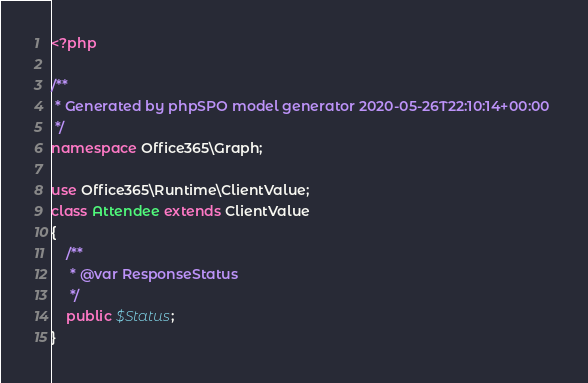<code> <loc_0><loc_0><loc_500><loc_500><_PHP_><?php

/**
 * Generated by phpSPO model generator 2020-05-26T22:10:14+00:00 
 */
namespace Office365\Graph;

use Office365\Runtime\ClientValue;
class Attendee extends ClientValue
{
    /**
     * @var ResponseStatus
     */
    public $Status;
}</code> 